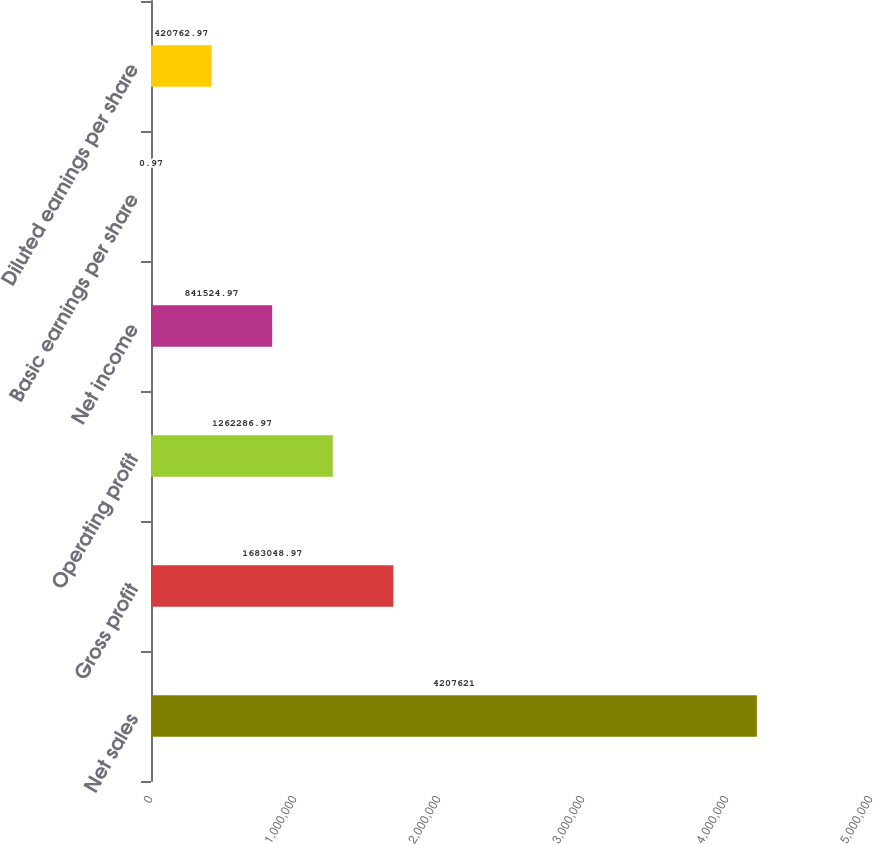<chart> <loc_0><loc_0><loc_500><loc_500><bar_chart><fcel>Net sales<fcel>Gross profit<fcel>Operating profit<fcel>Net income<fcel>Basic earnings per share<fcel>Diluted earnings per share<nl><fcel>4.20762e+06<fcel>1.68305e+06<fcel>1.26229e+06<fcel>841525<fcel>0.97<fcel>420763<nl></chart> 